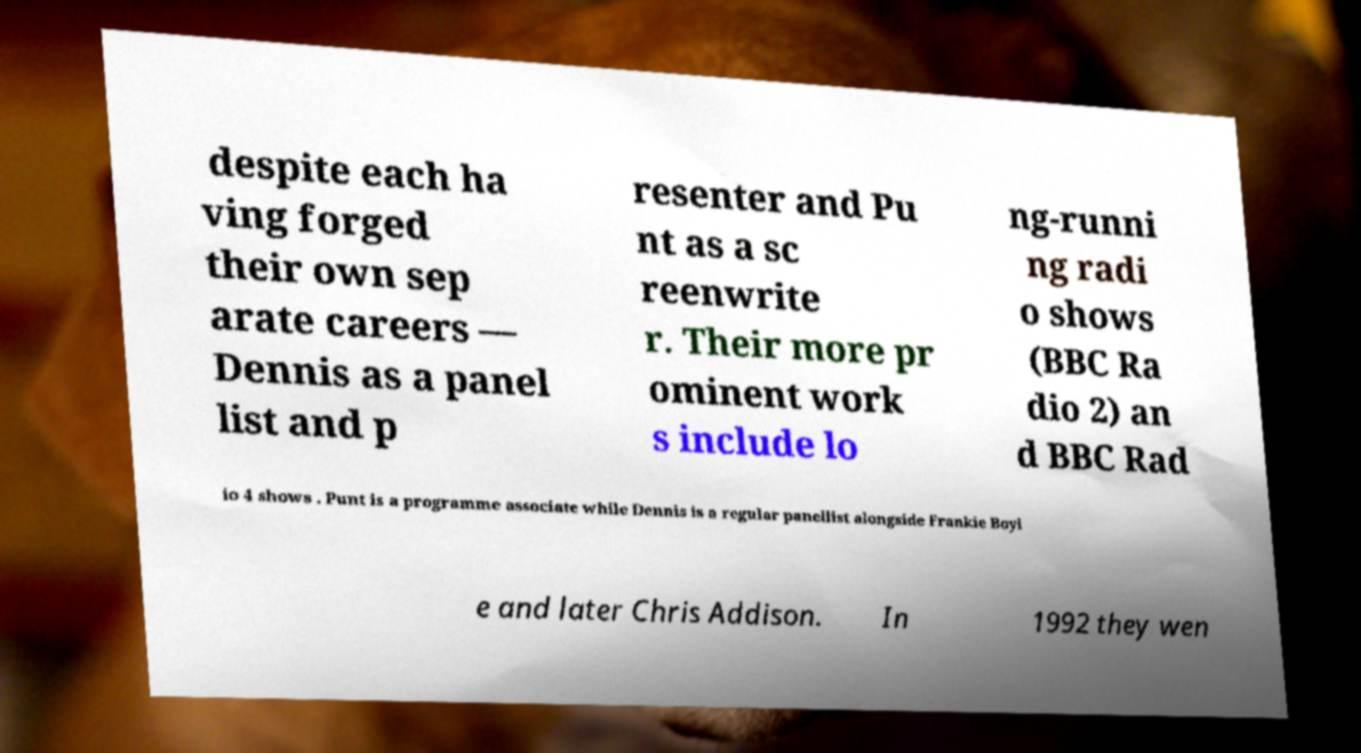Can you accurately transcribe the text from the provided image for me? despite each ha ving forged their own sep arate careers — Dennis as a panel list and p resenter and Pu nt as a sc reenwrite r. Their more pr ominent work s include lo ng-runni ng radi o shows (BBC Ra dio 2) an d BBC Rad io 4 shows . Punt is a programme associate while Dennis is a regular panellist alongside Frankie Boyl e and later Chris Addison. In 1992 they wen 